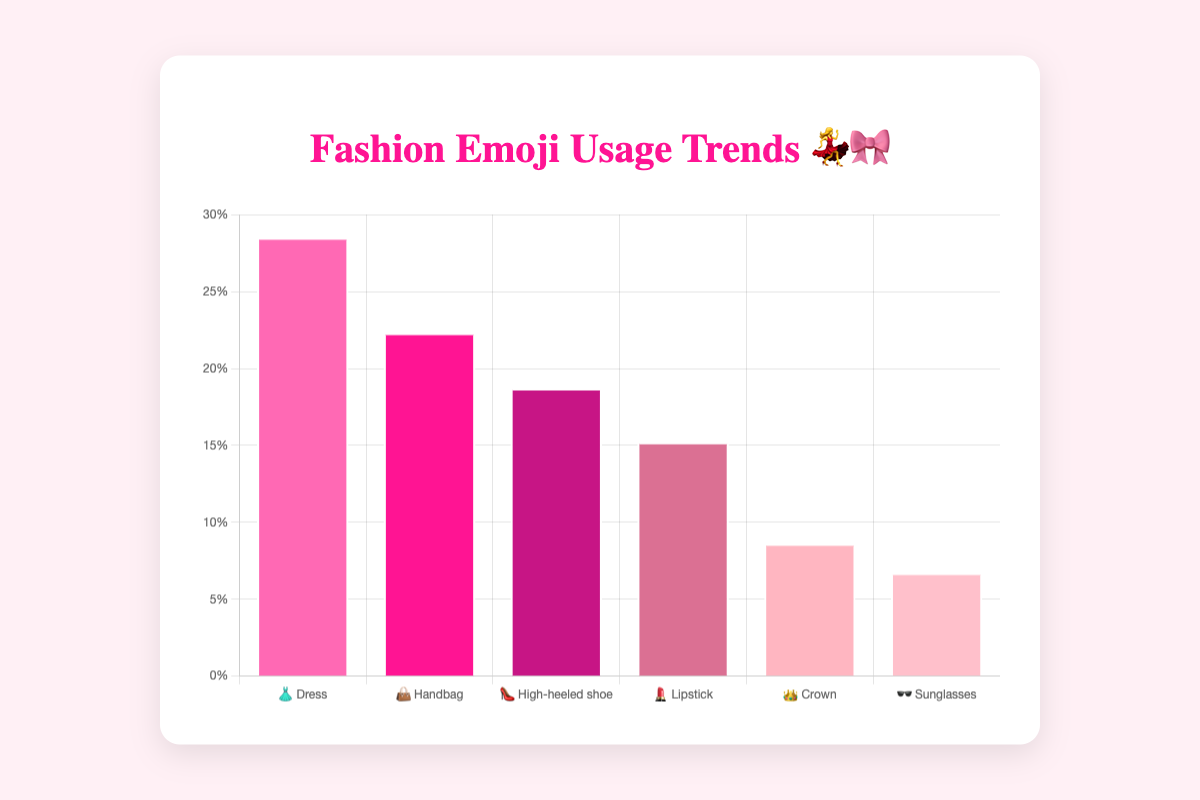Which emoji has the highest usage percentage? The dress emoji (👗) leads the chart with a 28.5% usage among fashion-related Instagram posts.
Answer: 👗 Dress What's the title of the chart? The title shown at the top of the chart is "Fashion Emoji Usage Trends 💃🎀".
Answer: Fashion Emoji Usage Trends 💃🎀 Which emoji is used less, the lipstick (💄) or the crown (👑)? By looking at the chart, the crown emoji (👑) is used less with a usage percentage of 8.6%, while the lipstick emoji (💄) has a higher usage at 15.2%.
Answer: 👑 Crown What is the combined usage percentage of the Dress (👗) and Handbag (👜) emojis? To find the combined usage, add the usage percentages of both emojis: 28.5% (👗) + 22.3% (👜) = 50.8%.
Answer: 50.8% Which emoji shows the least usage percentage and what could be potential reasons for this based on visual trends? The sunglasses emoji (🕶️) has the least usage at 6.7%. Potential reasons might include lesser relevance in typical fashion posts compared to other items like dresses and handbags.
Answer: 🕶️ Sunglasses How do the usage percentages of the high-heeled shoe (👠) and handbag (👜) emojis compare? The handbag emoji (👜) has a higher usage percentage at 22.3% compared to the high-heeled shoe emoji (👠) which stands at 18.7%.
Answer: 👜 Handbag What is the range of usage percentages for the emojis displayed in the chart? The range is calculated as the difference between the maximum and minimum usage percentages: 28.5% (👗) - 6.7% (🕶️) = 21.8%.
Answer: 21.8% Describe the color scheme used in the chart. The chart uses a palette of pink and related hues for the bars, enhancing the visual appeal and aligning with the fashion theme. This includes various shades like hot pink, deep pink, and light pink.
Answer: Pink and related hues What's the average usage percentage of all the emojis shown in the chart? To find the average usage percentage, sum all the usage percentages and divide by the number of emojis: (28.5 + 22.3 + 18.7 + 15.2 + 8.6 + 6.7) / 6 = 100 / 6 ≈ 16.67%.
Answer: 16.67% What percentage of the posts do not use the top two emojis (👗 & 👜)? First, calculate the combined usage of the top two emojis: 28.5% (👗) + 22.3% (👜) = 50.8%. Then, subtract this from 100% to find the percentage not using these emojis: 100% - 50.8% = 49.2%.
Answer: 49.2% 